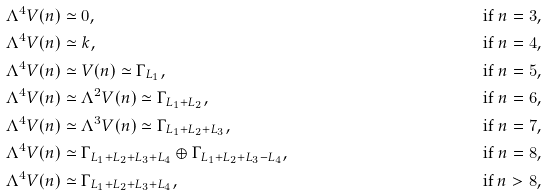Convert formula to latex. <formula><loc_0><loc_0><loc_500><loc_500>\Lambda ^ { 4 } V ( n ) & \simeq 0 , & \text {if $n=3$,} \\ \Lambda ^ { 4 } V ( n ) & \simeq k , & \text {if $n = 4$,} \\ \Lambda ^ { 4 } V ( n ) & \simeq V ( n ) \simeq \Gamma _ { L _ { 1 } } , & \text {if $n = 5$,} \\ \Lambda ^ { 4 } V ( n ) & \simeq \Lambda ^ { 2 } V ( n ) \simeq \Gamma _ { L _ { 1 } + L _ { 2 } } , & \text {if $n = 6$,} \\ \Lambda ^ { 4 } V ( n ) & \simeq \Lambda ^ { 3 } V ( n ) \simeq \Gamma _ { L _ { 1 } + L _ { 2 } + L _ { 3 } } , & \text {if $n = 7$,} \\ \Lambda ^ { 4 } V ( n ) & \simeq \Gamma _ { L _ { 1 } + L _ { 2 } + L _ { 3 } + L _ { 4 } } \oplus \Gamma _ { L _ { 1 } + L _ { 2 } + L _ { 3 } - L _ { 4 } } , & \text {if $n = 8$,} \\ \Lambda ^ { 4 } V ( n ) & \simeq \Gamma _ { L _ { 1 } + L _ { 2 } + L _ { 3 } + L _ { 4 } } , & \text {if $n > 8$,}</formula> 